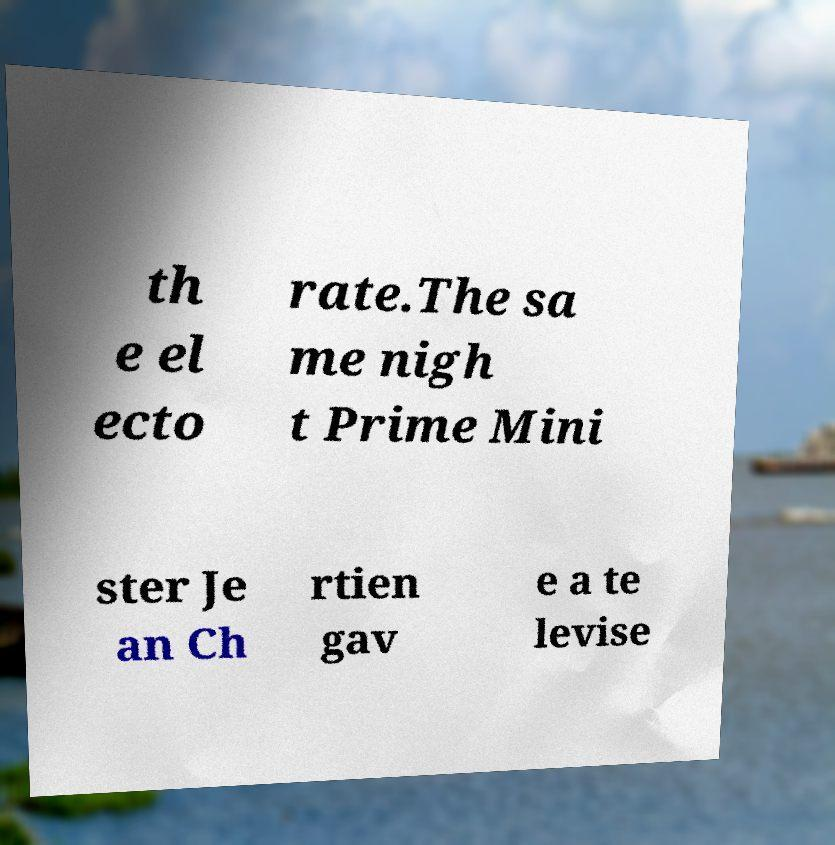Could you extract and type out the text from this image? th e el ecto rate.The sa me nigh t Prime Mini ster Je an Ch rtien gav e a te levise 